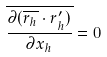<formula> <loc_0><loc_0><loc_500><loc_500>\overline { \frac { \partial ( \overline { r _ { h } } \cdot r _ { h } ^ { \prime } ) } { \partial x _ { h } } } = 0</formula> 